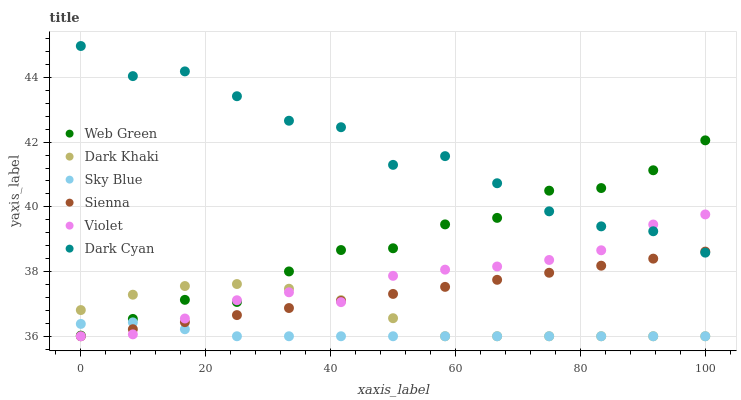Does Sky Blue have the minimum area under the curve?
Answer yes or no. Yes. Does Dark Cyan have the maximum area under the curve?
Answer yes or no. Yes. Does Web Green have the minimum area under the curve?
Answer yes or no. No. Does Web Green have the maximum area under the curve?
Answer yes or no. No. Is Sienna the smoothest?
Answer yes or no. Yes. Is Dark Cyan the roughest?
Answer yes or no. Yes. Is Web Green the smoothest?
Answer yes or no. No. Is Web Green the roughest?
Answer yes or no. No. Does Sienna have the lowest value?
Answer yes or no. Yes. Does Web Green have the lowest value?
Answer yes or no. No. Does Dark Cyan have the highest value?
Answer yes or no. Yes. Does Web Green have the highest value?
Answer yes or no. No. Is Sky Blue less than Dark Cyan?
Answer yes or no. Yes. Is Dark Cyan greater than Sky Blue?
Answer yes or no. Yes. Does Violet intersect Sky Blue?
Answer yes or no. Yes. Is Violet less than Sky Blue?
Answer yes or no. No. Is Violet greater than Sky Blue?
Answer yes or no. No. Does Sky Blue intersect Dark Cyan?
Answer yes or no. No. 